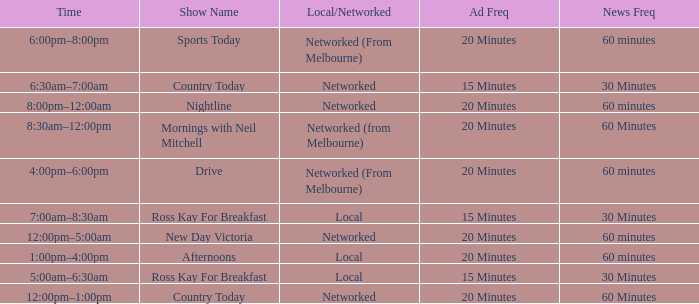What News Freq has a Time of 1:00pm–4:00pm? 60 minutes. 